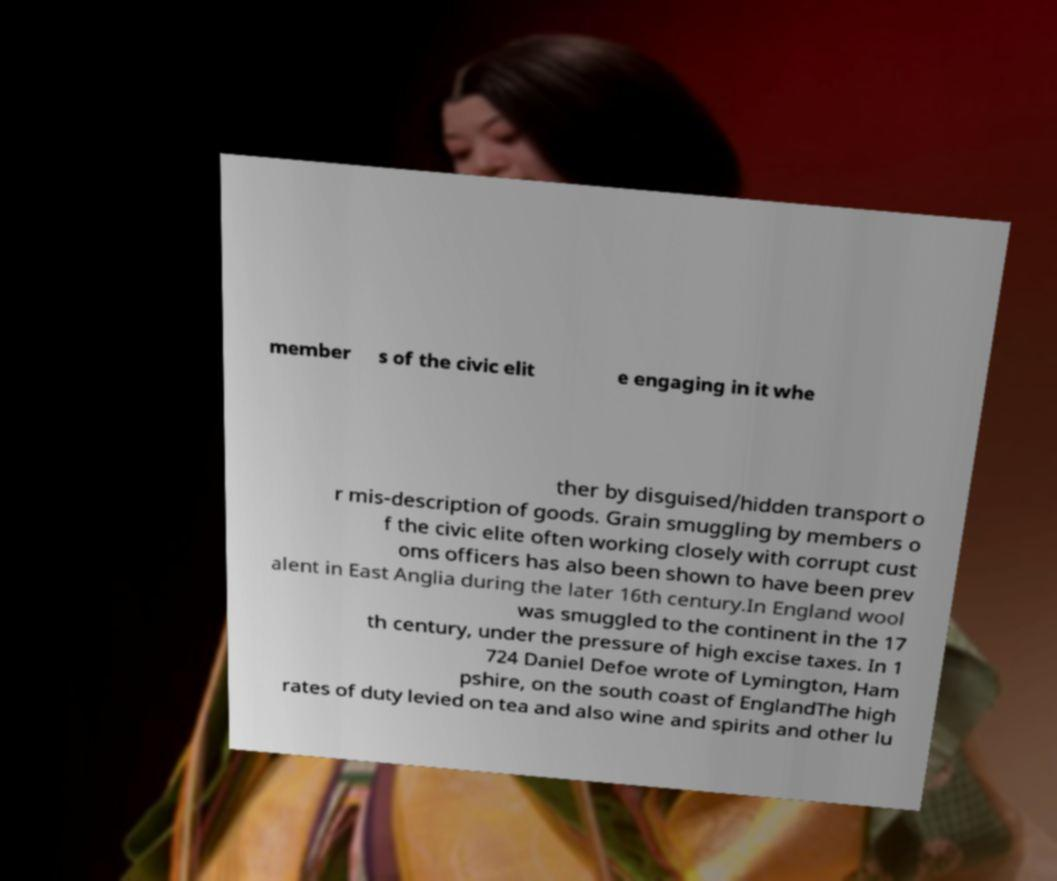Could you extract and type out the text from this image? member s of the civic elit e engaging in it whe ther by disguised/hidden transport o r mis-description of goods. Grain smuggling by members o f the civic elite often working closely with corrupt cust oms officers has also been shown to have been prev alent in East Anglia during the later 16th century.In England wool was smuggled to the continent in the 17 th century, under the pressure of high excise taxes. In 1 724 Daniel Defoe wrote of Lymington, Ham pshire, on the south coast of EnglandThe high rates of duty levied on tea and also wine and spirits and other lu 